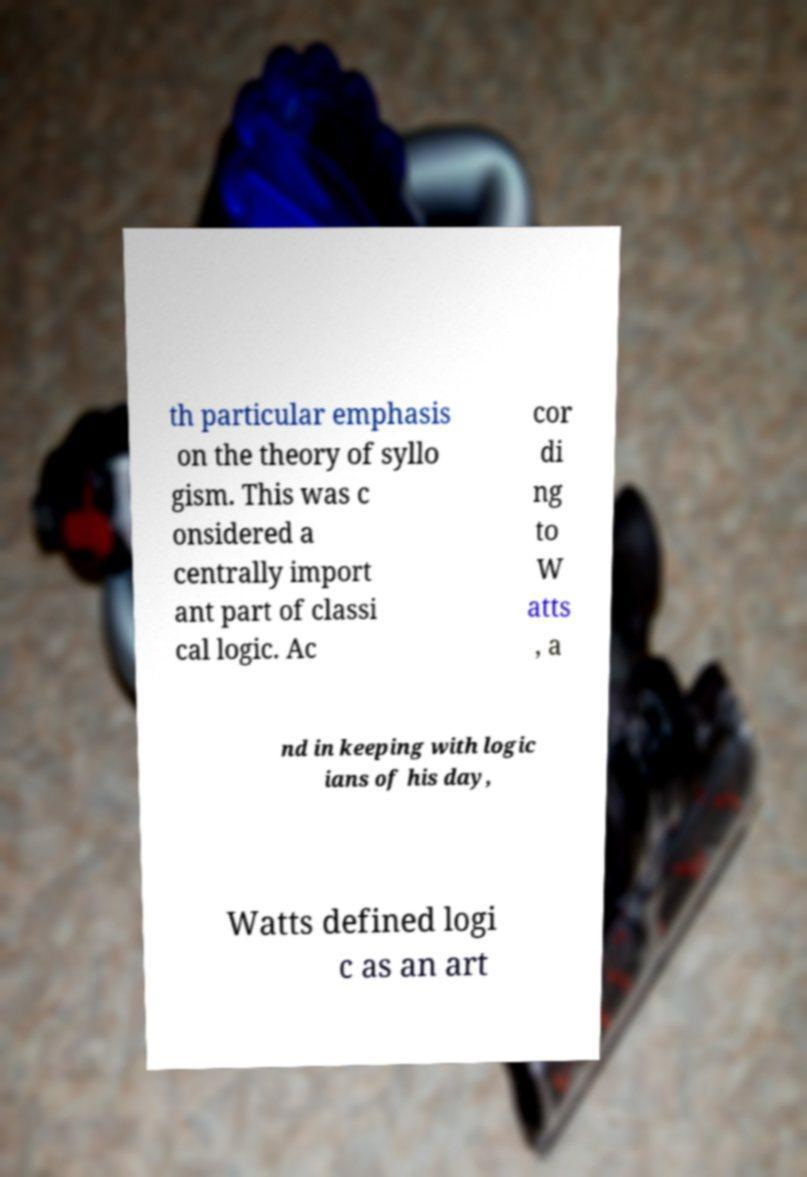Please identify and transcribe the text found in this image. th particular emphasis on the theory of syllo gism. This was c onsidered a centrally import ant part of classi cal logic. Ac cor di ng to W atts , a nd in keeping with logic ians of his day, Watts defined logi c as an art 